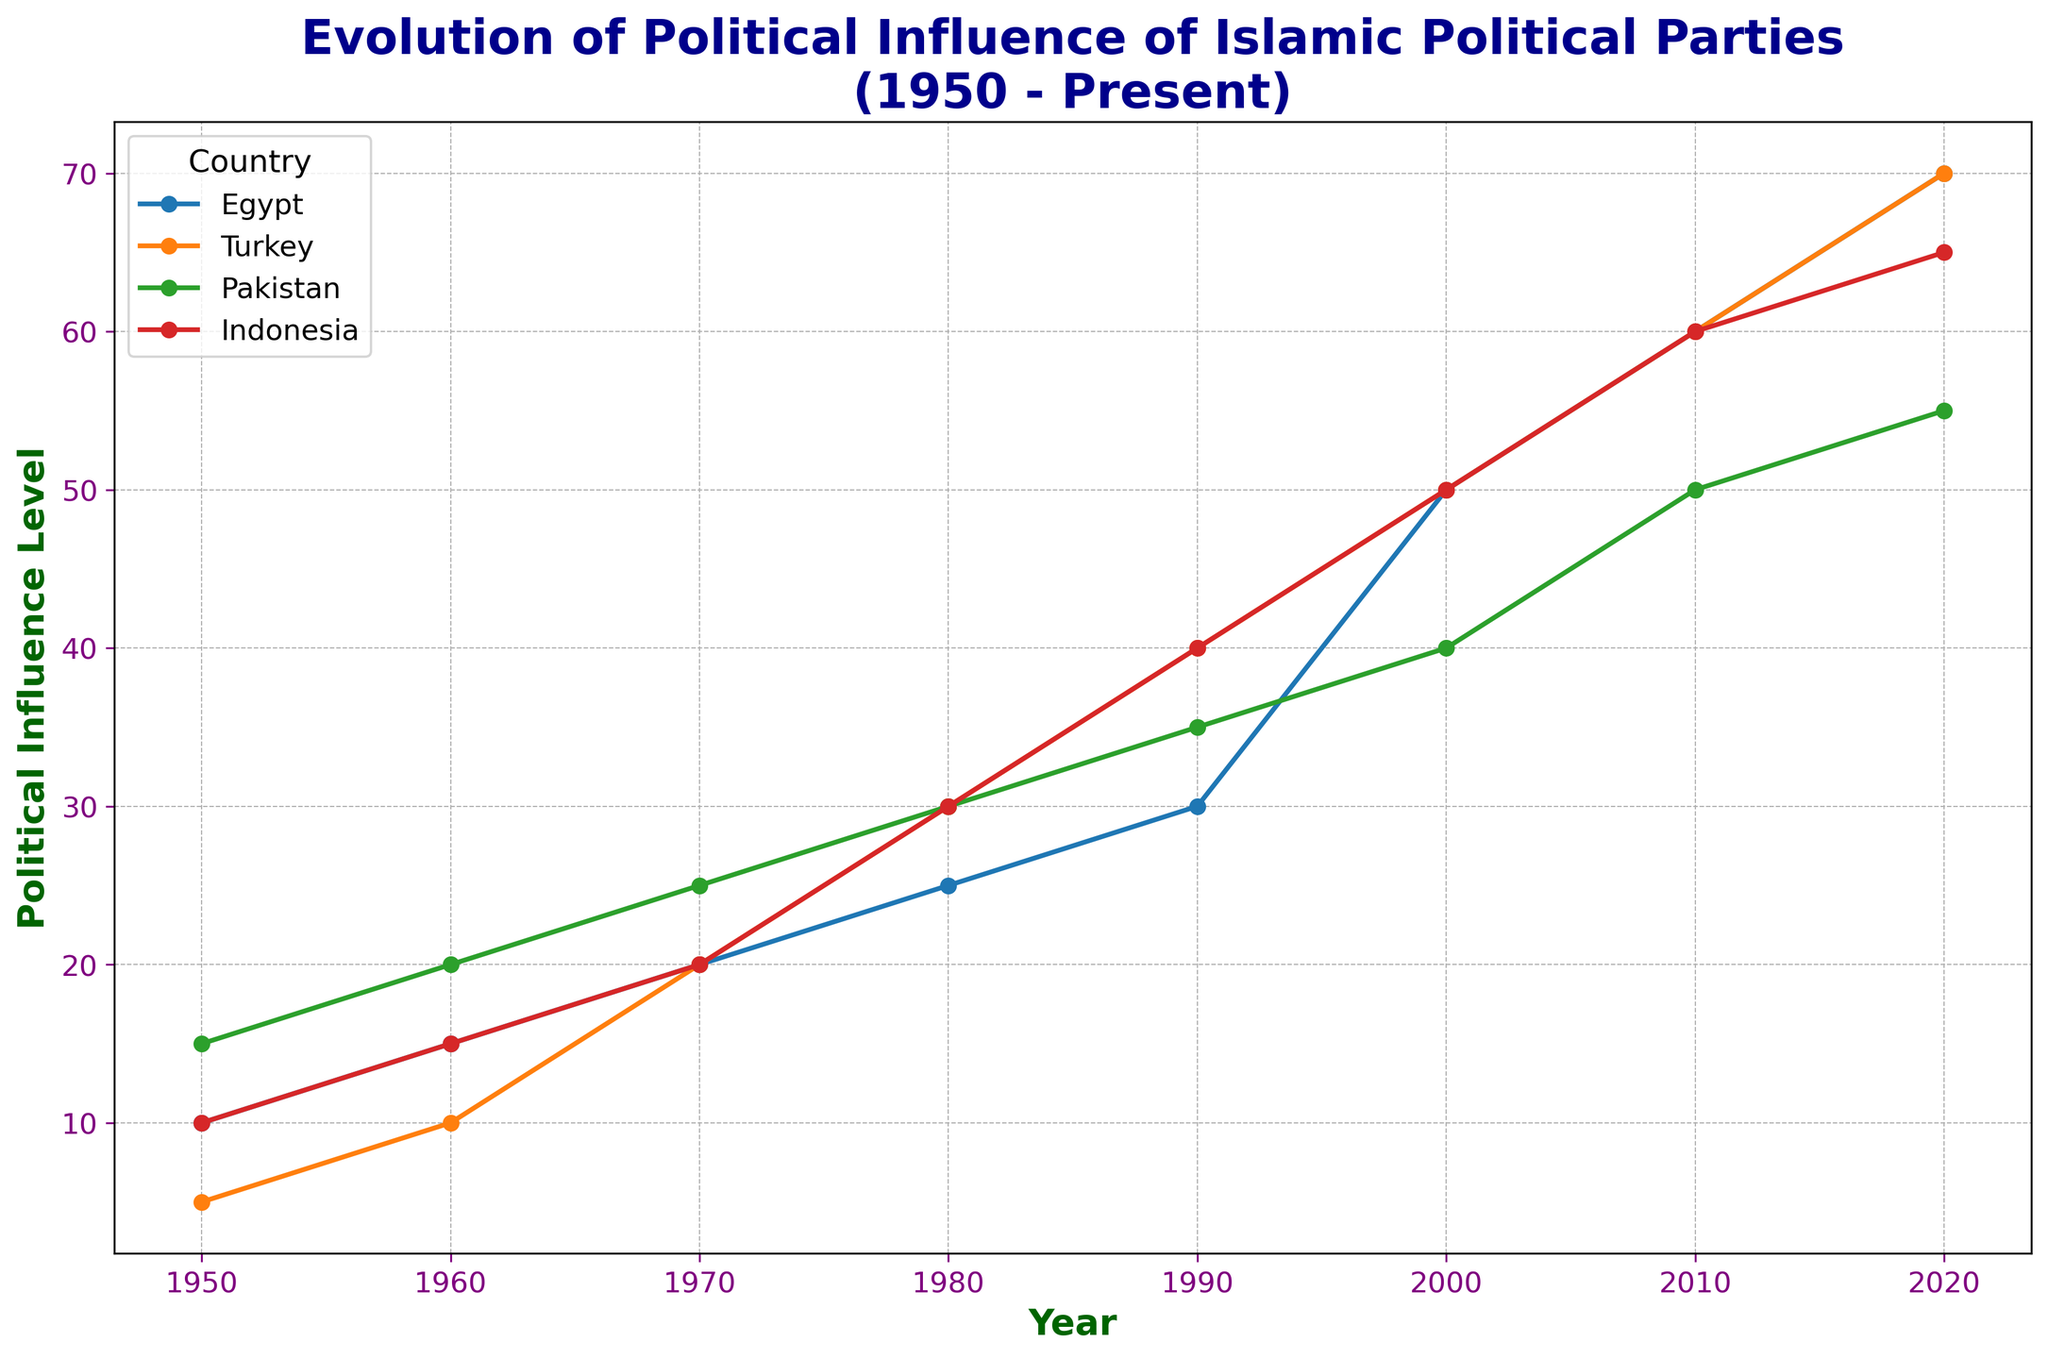What is the general trend of the political influence of Islamic political parties in Egypt from 1950 to 2020? Between 1950 and 2020, the political influence in Egypt increases consistently. Starting from 10 in 1950, it grows to 70 by 2020.
Answer: An upward trend Which country had the highest level of political influence of Islamic political parties in 1970? By visually inspecting the lines for the year 1970, Turkey and Pakistan both had an influence level of 20, which were equal and the highest among the countries.
Answer: Turkey and Pakistan How does the political influence of Islamic parties in Pakistan compare to that in Indonesia in 2020? The line for Pakistan reaches 55 in 2020, while the line for Indonesia reaches 65 for the same year. Therefore, Indonesia's level is higher.
Answer: Indonesia is higher Which country's political influence shows the most significant jump between two consecutive decades, and what are those decades? By examining the slopes of the lines, the most prominent increase is seen in Egypt between 1990 and 2000, where the level jumps from 30 to 50.
Answer: Egypt between 1990 and 2000 What is the average political influence level of Islamic political parties in Turkey from 1950 to 2020? To find the average: (5 + 10 + 20 + 30 + 40 + 50 + 60 + 70) / 8 = 35.
Answer: 35 In which decade did Indonesia’s political influence experience the highest increase, and what is the value of that increase? The most significant increase in Indonesia occurs between 1960 and 1970, which went from 15 to 20, an increase of 15.
Answer: 1970s with an increase of 10 Between 2000 and 2010, which country saw the smallest change in the political influence of Islamic political parties? By analyzing the changes for each country during this period: Egypt increased by 10, Turkey by 10, Pakistan by 10, and Indonesia by 10. Each country had the same smallest change.
Answer: All countries, with a change of 10 If you sum the political influences of Islamic political parties in all four countries in 2010, what total do you get? Summing the values for 2010: Egypt (60) + Turkey (60) + Pakistan (50) + Indonesia (60) = 230.
Answer: 230 What pattern is observable for Turkey's political influence levels over the decades from 1950 to 2020? Turkey’s political influence shows a consistent increase over the decades, starting from 5 in 1950 and reaching 70 by 2020, indicating a steady growth pattern.
Answer: Steady increase Compare the political influence growth rate of Egypt from 1950 to 1990 with that from 1990 to 2020? From 1950 to 1990, Egypt’s political influence grows from 10 to 30 (an increase of 20). From 1990 to 2020, it grows from 30 to 70 (an increase of 40). Thus, the later growth rate is higher.
Answer: The rate from 1990 to 2020 is higher 